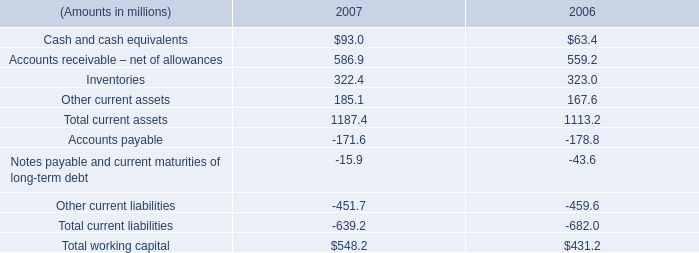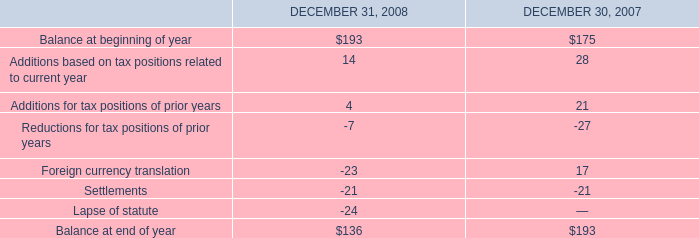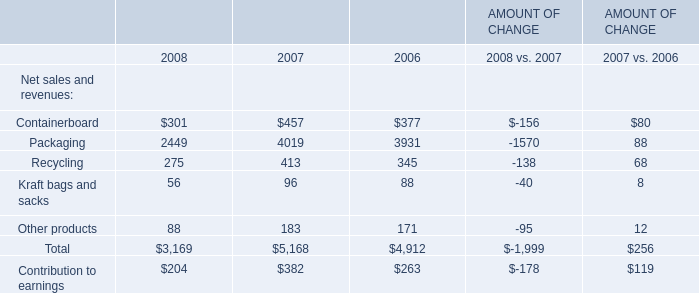what is the percentage change in total current assets from 2006 to 2007? 
Computations: ((1187.4 - 1113.2) / 1113.2)
Answer: 0.06665. 